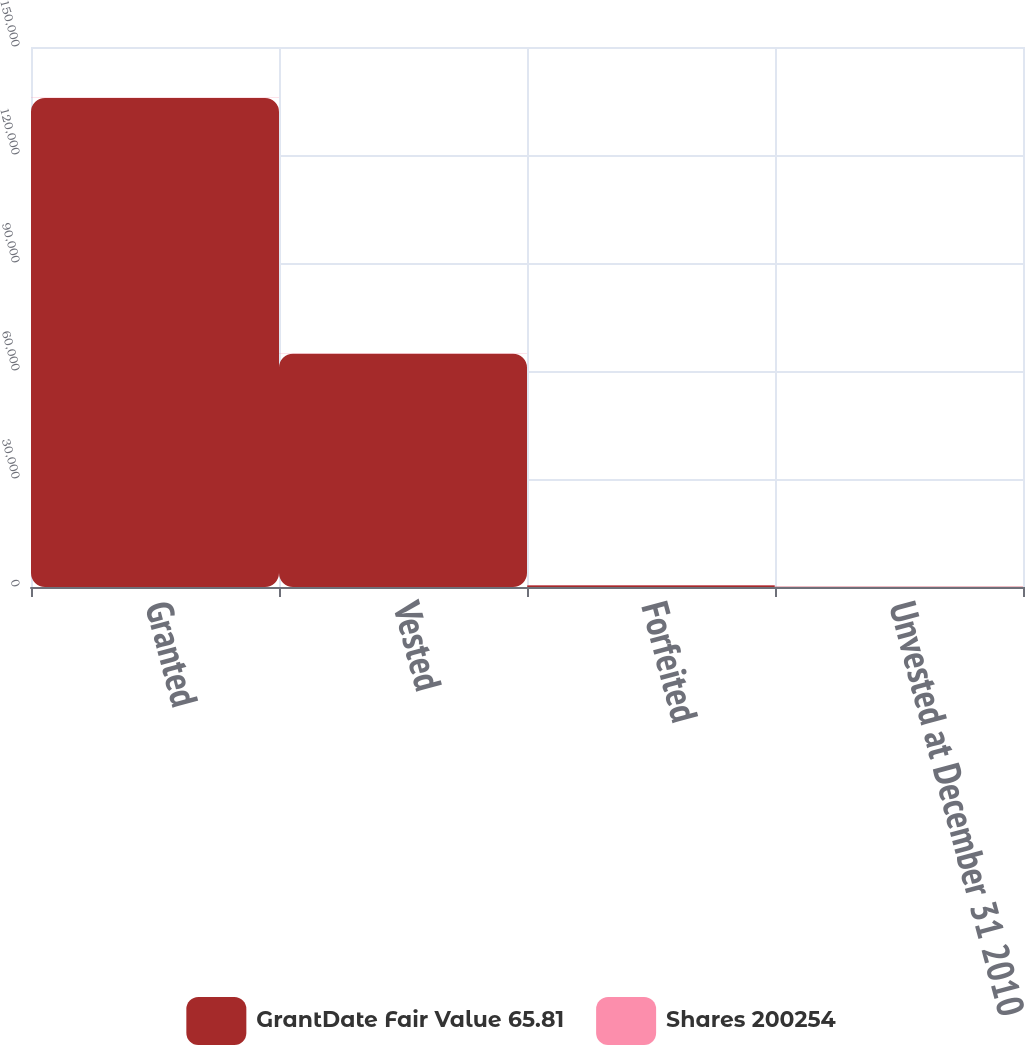Convert chart to OTSL. <chart><loc_0><loc_0><loc_500><loc_500><stacked_bar_chart><ecel><fcel>Granted<fcel>Vested<fcel>Forfeited<fcel>Unvested at December 31 2010<nl><fcel>GrantDate Fair Value 65.81<fcel>135833<fcel>64799<fcel>495<fcel>89.06<nl><fcel>Shares 200254<fcel>73.51<fcel>72.41<fcel>89.06<fcel>68.07<nl></chart> 